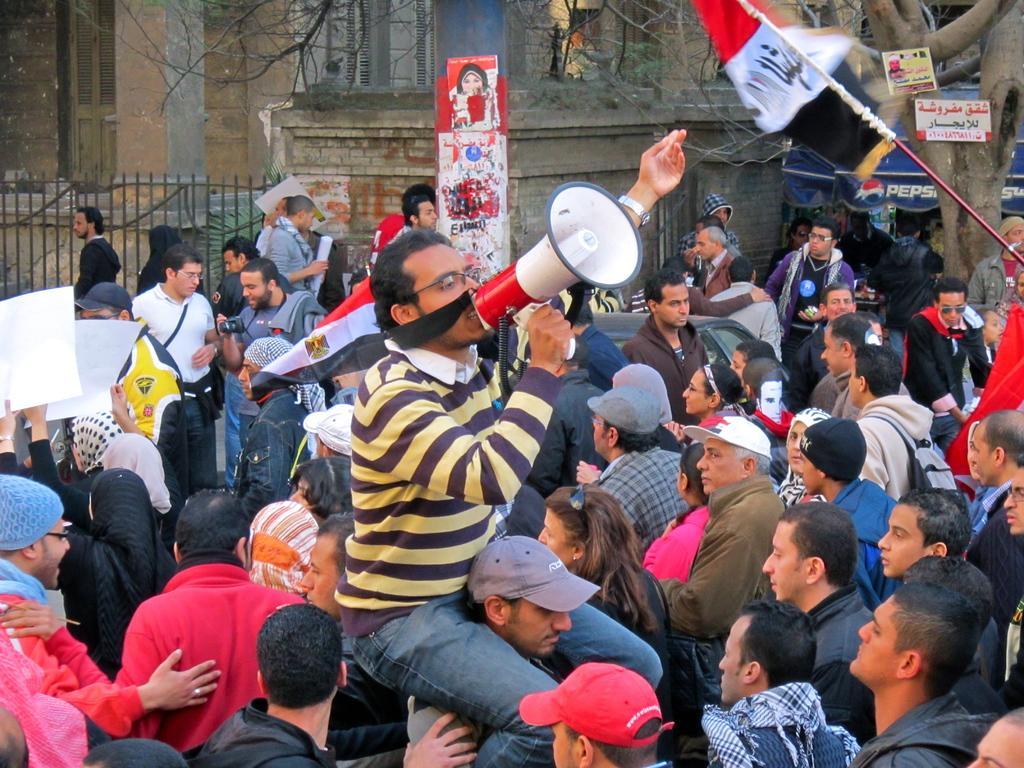How would you summarize this image in a sentence or two? There is a group of persons standing at the bottom of this image and there is a building in the background. There is a tree on the right side of this image and there is a fencing on the left side of this image. 